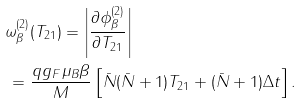Convert formula to latex. <formula><loc_0><loc_0><loc_500><loc_500>& \omega ^ { ( 2 ) } _ { \beta } ( T _ { 2 1 } ) = \left | \frac { \partial \phi ^ { ( 2 ) } _ { \beta } } { \partial T _ { 2 1 } } \right | \\ & \, = \frac { q g _ { F } \mu _ { B } \beta } { M } \left [ \bar { N } ( \bar { N } + 1 ) T _ { 2 1 } + ( \bar { N } + 1 ) \Delta t \right ] .</formula> 